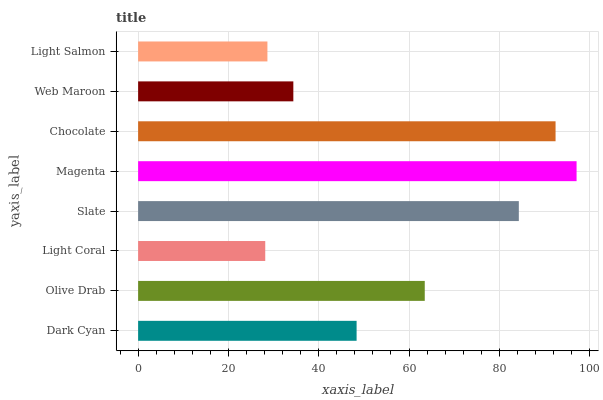Is Light Coral the minimum?
Answer yes or no. Yes. Is Magenta the maximum?
Answer yes or no. Yes. Is Olive Drab the minimum?
Answer yes or no. No. Is Olive Drab the maximum?
Answer yes or no. No. Is Olive Drab greater than Dark Cyan?
Answer yes or no. Yes. Is Dark Cyan less than Olive Drab?
Answer yes or no. Yes. Is Dark Cyan greater than Olive Drab?
Answer yes or no. No. Is Olive Drab less than Dark Cyan?
Answer yes or no. No. Is Olive Drab the high median?
Answer yes or no. Yes. Is Dark Cyan the low median?
Answer yes or no. Yes. Is Web Maroon the high median?
Answer yes or no. No. Is Light Coral the low median?
Answer yes or no. No. 